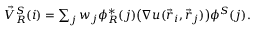<formula> <loc_0><loc_0><loc_500><loc_500>\begin{array} { r } { \vec { V } _ { R } ^ { S } ( i ) = \sum _ { j } w _ { j } \phi _ { R } ^ { * } ( j ) \left ( \nabla u ( \vec { r } _ { i } , \vec { r } _ { j } ) \right ) \phi ^ { S } ( j ) . } \end{array}</formula> 